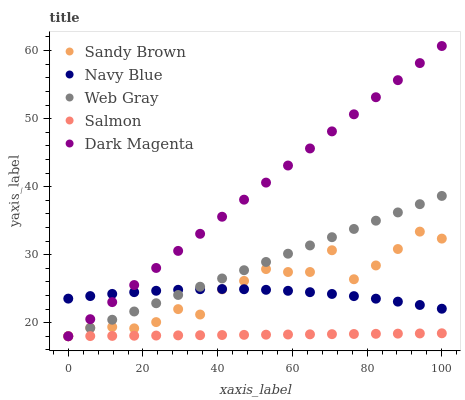Does Salmon have the minimum area under the curve?
Answer yes or no. Yes. Does Dark Magenta have the maximum area under the curve?
Answer yes or no. Yes. Does Web Gray have the minimum area under the curve?
Answer yes or no. No. Does Web Gray have the maximum area under the curve?
Answer yes or no. No. Is Salmon the smoothest?
Answer yes or no. Yes. Is Sandy Brown the roughest?
Answer yes or no. Yes. Is Web Gray the smoothest?
Answer yes or no. No. Is Web Gray the roughest?
Answer yes or no. No. Does Web Gray have the lowest value?
Answer yes or no. Yes. Does Dark Magenta have the highest value?
Answer yes or no. Yes. Does Web Gray have the highest value?
Answer yes or no. No. Is Salmon less than Navy Blue?
Answer yes or no. Yes. Is Navy Blue greater than Salmon?
Answer yes or no. Yes. Does Salmon intersect Sandy Brown?
Answer yes or no. Yes. Is Salmon less than Sandy Brown?
Answer yes or no. No. Is Salmon greater than Sandy Brown?
Answer yes or no. No. Does Salmon intersect Navy Blue?
Answer yes or no. No. 